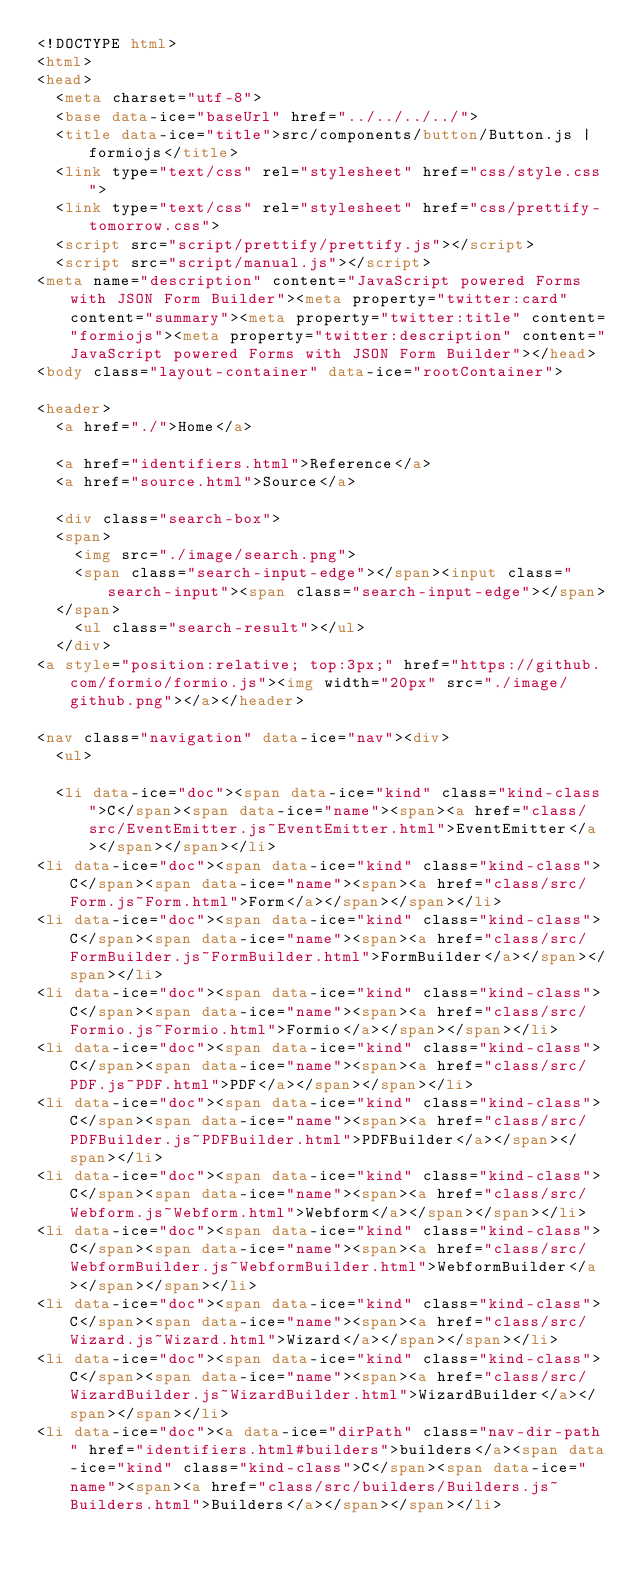Convert code to text. <code><loc_0><loc_0><loc_500><loc_500><_HTML_><!DOCTYPE html>
<html>
<head>
  <meta charset="utf-8">
  <base data-ice="baseUrl" href="../../../../">
  <title data-ice="title">src/components/button/Button.js | formiojs</title>
  <link type="text/css" rel="stylesheet" href="css/style.css">
  <link type="text/css" rel="stylesheet" href="css/prettify-tomorrow.css">
  <script src="script/prettify/prettify.js"></script>
  <script src="script/manual.js"></script>
<meta name="description" content="JavaScript powered Forms with JSON Form Builder"><meta property="twitter:card" content="summary"><meta property="twitter:title" content="formiojs"><meta property="twitter:description" content="JavaScript powered Forms with JSON Form Builder"></head>
<body class="layout-container" data-ice="rootContainer">

<header>
  <a href="./">Home</a>
  
  <a href="identifiers.html">Reference</a>
  <a href="source.html">Source</a>
  
  <div class="search-box">
  <span>
    <img src="./image/search.png">
    <span class="search-input-edge"></span><input class="search-input"><span class="search-input-edge"></span>
  </span>
    <ul class="search-result"></ul>
  </div>
<a style="position:relative; top:3px;" href="https://github.com/formio/formio.js"><img width="20px" src="./image/github.png"></a></header>

<nav class="navigation" data-ice="nav"><div>
  <ul>
    
  <li data-ice="doc"><span data-ice="kind" class="kind-class">C</span><span data-ice="name"><span><a href="class/src/EventEmitter.js~EventEmitter.html">EventEmitter</a></span></span></li>
<li data-ice="doc"><span data-ice="kind" class="kind-class">C</span><span data-ice="name"><span><a href="class/src/Form.js~Form.html">Form</a></span></span></li>
<li data-ice="doc"><span data-ice="kind" class="kind-class">C</span><span data-ice="name"><span><a href="class/src/FormBuilder.js~FormBuilder.html">FormBuilder</a></span></span></li>
<li data-ice="doc"><span data-ice="kind" class="kind-class">C</span><span data-ice="name"><span><a href="class/src/Formio.js~Formio.html">Formio</a></span></span></li>
<li data-ice="doc"><span data-ice="kind" class="kind-class">C</span><span data-ice="name"><span><a href="class/src/PDF.js~PDF.html">PDF</a></span></span></li>
<li data-ice="doc"><span data-ice="kind" class="kind-class">C</span><span data-ice="name"><span><a href="class/src/PDFBuilder.js~PDFBuilder.html">PDFBuilder</a></span></span></li>
<li data-ice="doc"><span data-ice="kind" class="kind-class">C</span><span data-ice="name"><span><a href="class/src/Webform.js~Webform.html">Webform</a></span></span></li>
<li data-ice="doc"><span data-ice="kind" class="kind-class">C</span><span data-ice="name"><span><a href="class/src/WebformBuilder.js~WebformBuilder.html">WebformBuilder</a></span></span></li>
<li data-ice="doc"><span data-ice="kind" class="kind-class">C</span><span data-ice="name"><span><a href="class/src/Wizard.js~Wizard.html">Wizard</a></span></span></li>
<li data-ice="doc"><span data-ice="kind" class="kind-class">C</span><span data-ice="name"><span><a href="class/src/WizardBuilder.js~WizardBuilder.html">WizardBuilder</a></span></span></li>
<li data-ice="doc"><a data-ice="dirPath" class="nav-dir-path" href="identifiers.html#builders">builders</a><span data-ice="kind" class="kind-class">C</span><span data-ice="name"><span><a href="class/src/builders/Builders.js~Builders.html">Builders</a></span></span></li></code> 